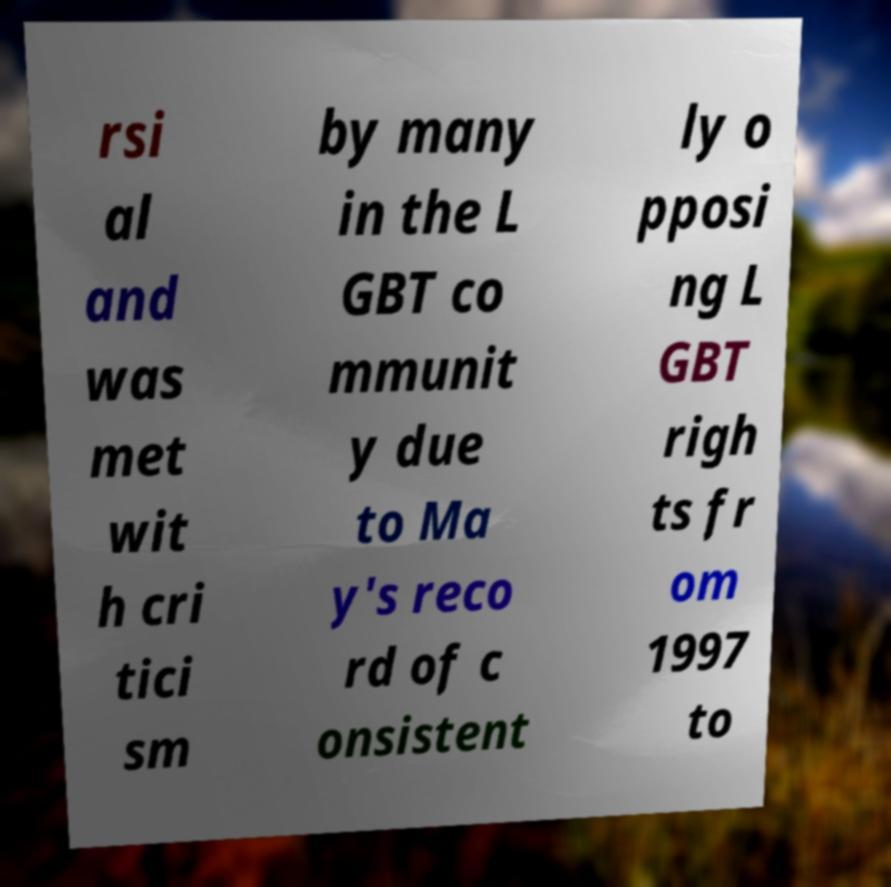Please identify and transcribe the text found in this image. rsi al and was met wit h cri tici sm by many in the L GBT co mmunit y due to Ma y's reco rd of c onsistent ly o pposi ng L GBT righ ts fr om 1997 to 